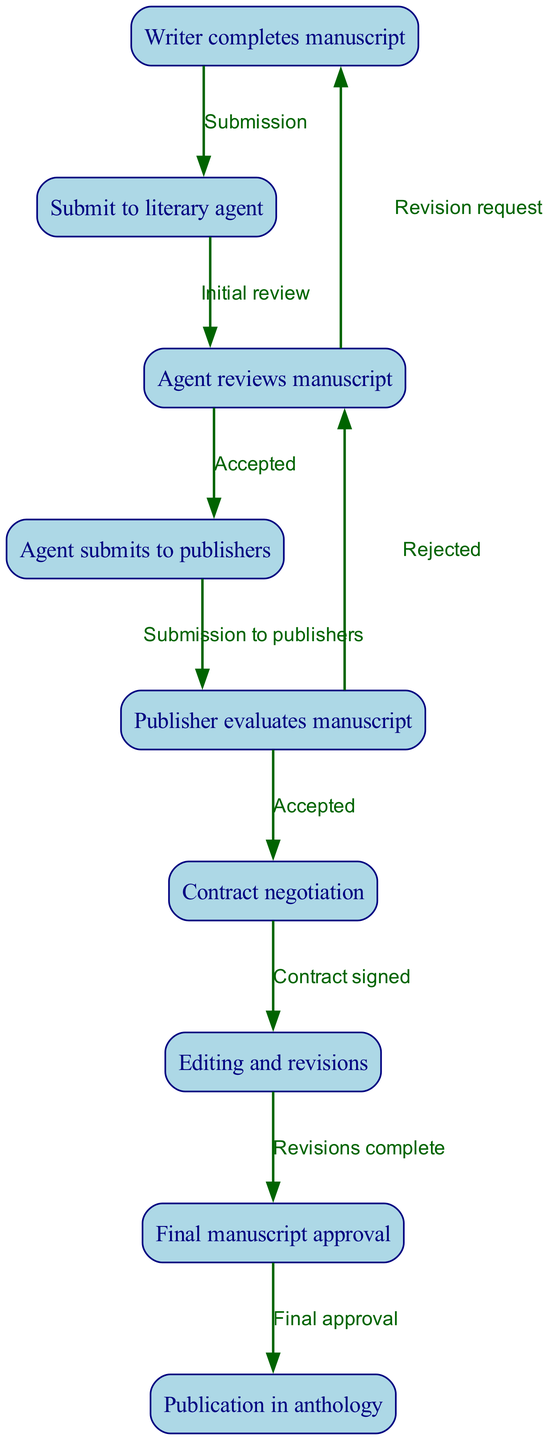What is the first node in the flowchart? The flowchart starts with the node labeled "Writer completes manuscript", which is the initial step in the process of manuscript publishing.
Answer: Writer completes manuscript How many nodes are in the diagram? To find the number of nodes, we count each individual step represented in the diagram, which includes all the distinct processes from the writer completing the manuscript to publication. There are a total of nine nodes.
Answer: 9 What step follows "Contract negotiation"? After the "Contract negotiation" step, the next action taken is "Editing and revisions", which is the phase where the manuscript is prepared based on the contract signed.
Answer: Editing and revisions What does the edge labeled “Accepted” connect? The edge labeled "Accepted" connects the nodes "Agent reviews manuscript" and "Agent submits to publishers", indicating a successful transition after the agent's review.
Answer: Agent reviews manuscript and Agent submits to publishers What happens if the publisher evaluates the manuscript and decides to reject it? If the publisher evaluates the manuscript and chooses to reject it, the flowchart indicates that the process returns to "Agent reviews manuscript" for potential revisions. This illustrates a feedback loop where the manuscript may require further improvement.
Answer: Returns to Agent reviews manuscript What is the final step in the manuscript process? The last node in the flowchart is “Publication in anthology”, which represents the completed process of getting the manuscript published after all approvals and revisions are finished.
Answer: Publication in anthology Which nodes have feedback loops? The feedback loops in the diagram occur between "Agent reviews manuscript" and "Writer completes manuscript", as well as between "Publisher evaluates manuscript" and "Agent reviews manuscript", indicating places where revisions are requested.
Answer: Agent reviews manuscript and Publisher evaluates manuscript How many edges connect to the "Editing and revisions" node? The node "Editing and revisions" has only one edge leading to it, which is from "Contract negotiation", indicating the singular flow into the revisions phase.
Answer: 1 What action takes place after "Editing and revisions"? After the "Editing and revisions" phase is complete, the next action is "Final manuscript approval", marking it as the final step before publication.
Answer: Final manuscript approval 